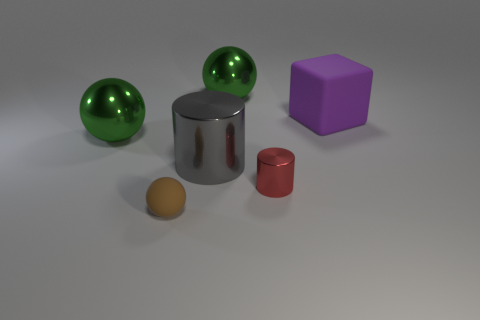Are the brown object and the small object to the right of the gray cylinder made of the same material?
Your answer should be very brief. No. Are there fewer tiny red things behind the tiny red metal thing than brown spheres in front of the brown rubber ball?
Provide a short and direct response. No. What material is the big thing behind the large cube?
Offer a very short reply. Metal. There is a object that is both on the right side of the large gray metallic thing and on the left side of the tiny red thing; what color is it?
Provide a short and direct response. Green. How many other things are the same color as the large metal cylinder?
Offer a very short reply. 0. What color is the sphere that is to the right of the big cylinder?
Give a very brief answer. Green. Is there a cyan metal sphere of the same size as the red object?
Provide a succinct answer. No. There is a purple cube that is the same size as the gray cylinder; what is it made of?
Give a very brief answer. Rubber. What number of objects are red cylinders in front of the purple cube or objects that are to the left of the cube?
Your answer should be very brief. 5. Is there a big green metal thing that has the same shape as the small brown object?
Provide a succinct answer. Yes. 